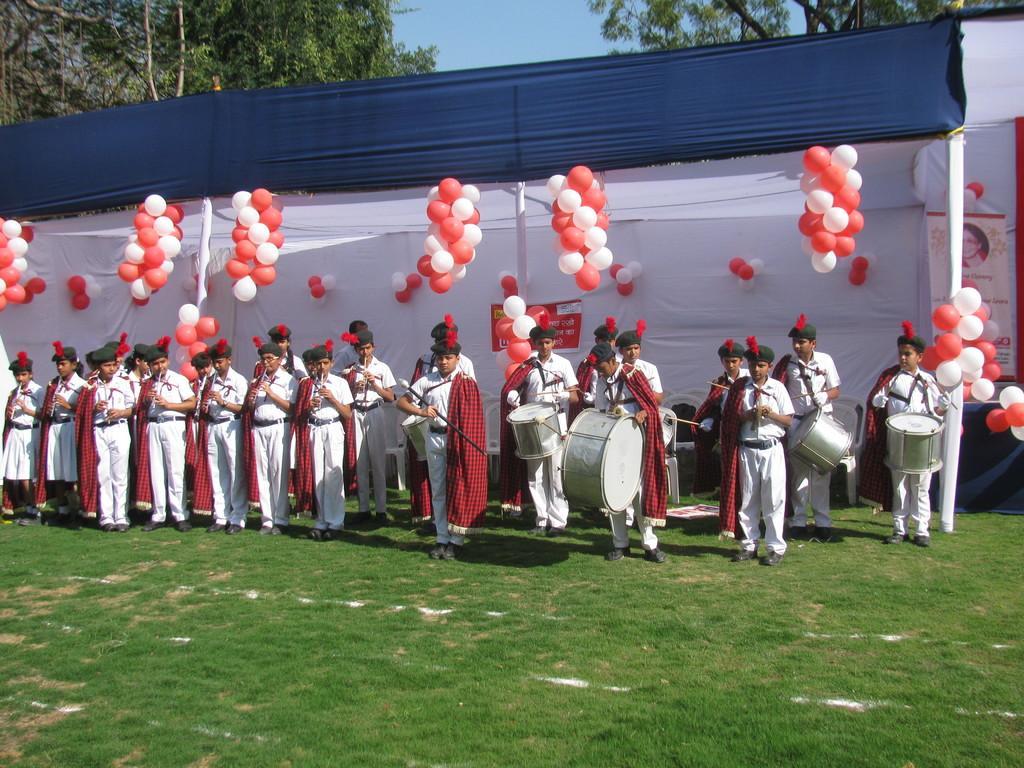Can you describe this image briefly? In this image we can see few persons are playing musical instruments by standing on the ground and we can see grass on the ground. In the background we can see clothes, balloons, poles, hoarding, trees and the sky. 